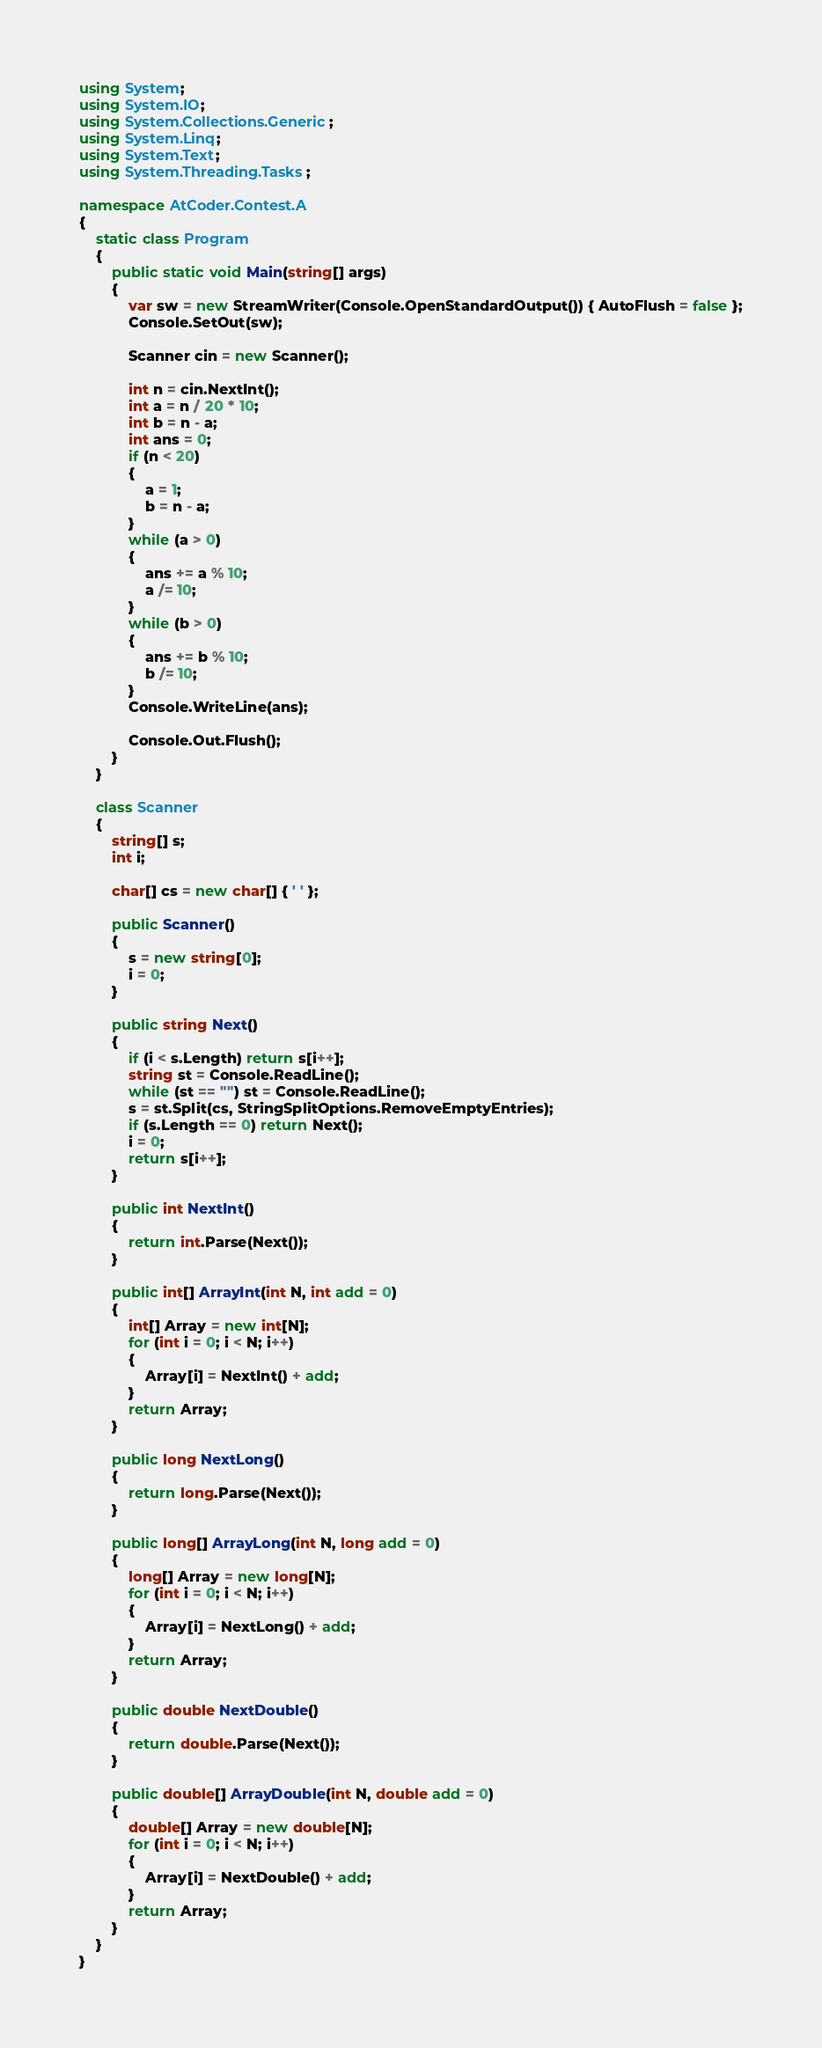Convert code to text. <code><loc_0><loc_0><loc_500><loc_500><_C#_>using System;
using System.IO;
using System.Collections.Generic;
using System.Linq;
using System.Text;
using System.Threading.Tasks;

namespace AtCoder.Contest.A
{
	static class Program
	{
		public static void Main(string[] args)
		{
			var sw = new StreamWriter(Console.OpenStandardOutput()) { AutoFlush = false };
			Console.SetOut(sw);

			Scanner cin = new Scanner();

			int n = cin.NextInt();
			int a = n / 20 * 10;
			int b = n - a;
			int ans = 0;
			if (n < 20)
			{
				a = 1;
				b = n - a;
			}
			while (a > 0)
			{
				ans += a % 10;
				a /= 10;
			}
			while (b > 0)
			{
				ans += b % 10;
				b /= 10;
			}
			Console.WriteLine(ans);

			Console.Out.Flush();
		}
	}

	class Scanner
	{
		string[] s;
		int i;

		char[] cs = new char[] { ' ' };

		public Scanner()
		{
			s = new string[0];
			i = 0;
		}

		public string Next()
		{
			if (i < s.Length) return s[i++];
			string st = Console.ReadLine();
			while (st == "") st = Console.ReadLine();
			s = st.Split(cs, StringSplitOptions.RemoveEmptyEntries);
			if (s.Length == 0) return Next();
			i = 0;
			return s[i++];
		}

		public int NextInt()
		{
			return int.Parse(Next());
		}

		public int[] ArrayInt(int N, int add = 0)
		{
			int[] Array = new int[N];
			for (int i = 0; i < N; i++)
			{
				Array[i] = NextInt() + add;
			}
			return Array;
		}

		public long NextLong()
		{
			return long.Parse(Next());
		}

		public long[] ArrayLong(int N, long add = 0)
		{
			long[] Array = new long[N];
			for (int i = 0; i < N; i++)
			{
				Array[i] = NextLong() + add;
			}
			return Array;
		}

		public double NextDouble()
		{
			return double.Parse(Next());
		}

		public double[] ArrayDouble(int N, double add = 0)
		{
			double[] Array = new double[N];
			for (int i = 0; i < N; i++)
			{
				Array[i] = NextDouble() + add;
			}
			return Array;
		}
	}
}</code> 